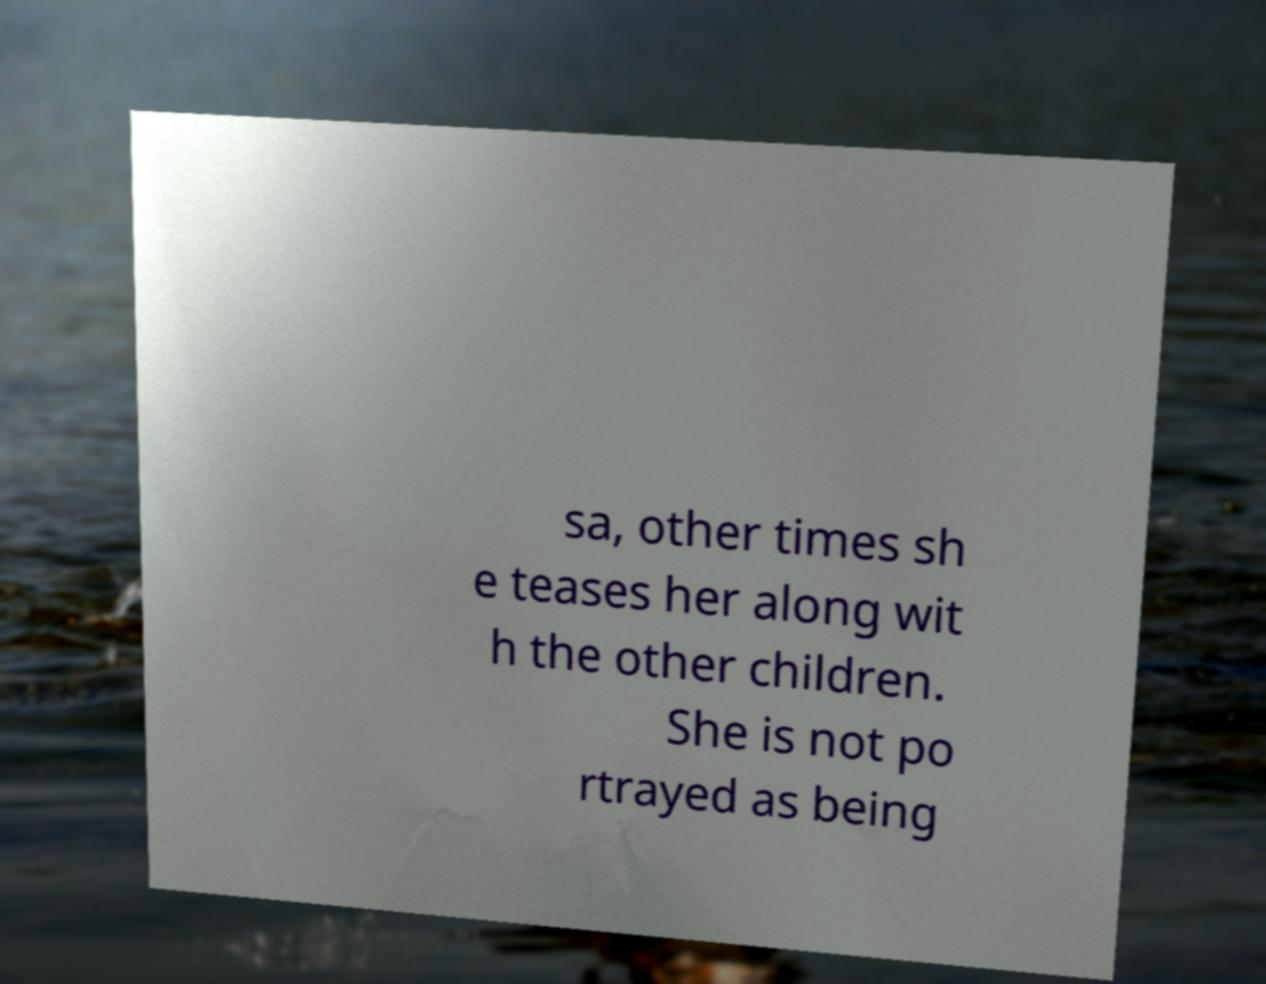Can you read and provide the text displayed in the image?This photo seems to have some interesting text. Can you extract and type it out for me? sa, other times sh e teases her along wit h the other children. She is not po rtrayed as being 